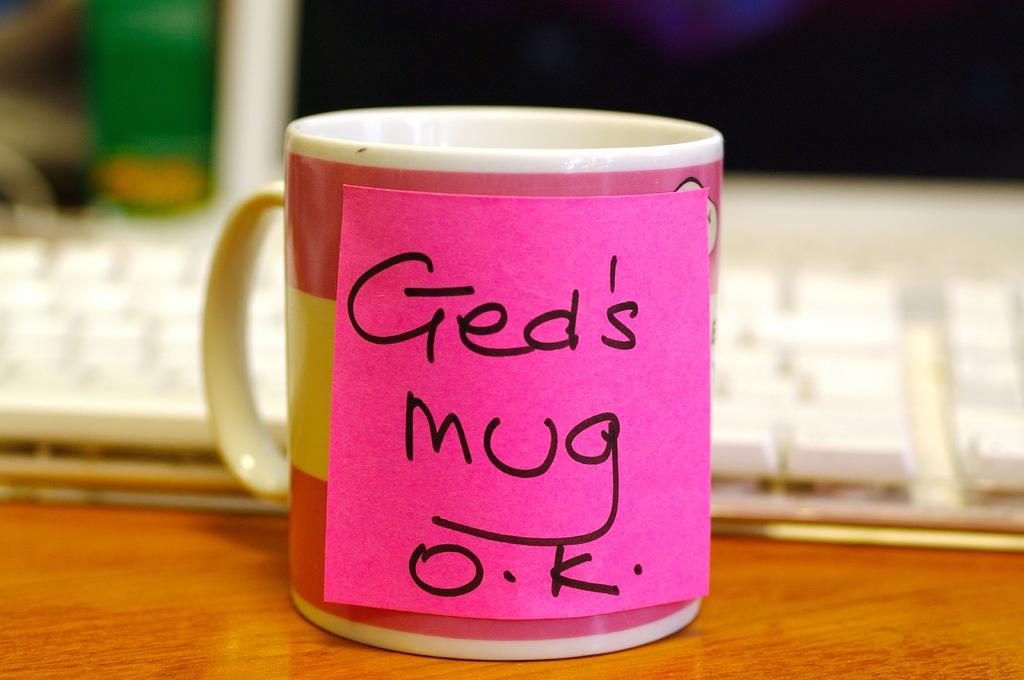Who's mug is it?
Your response must be concise. Ged. 